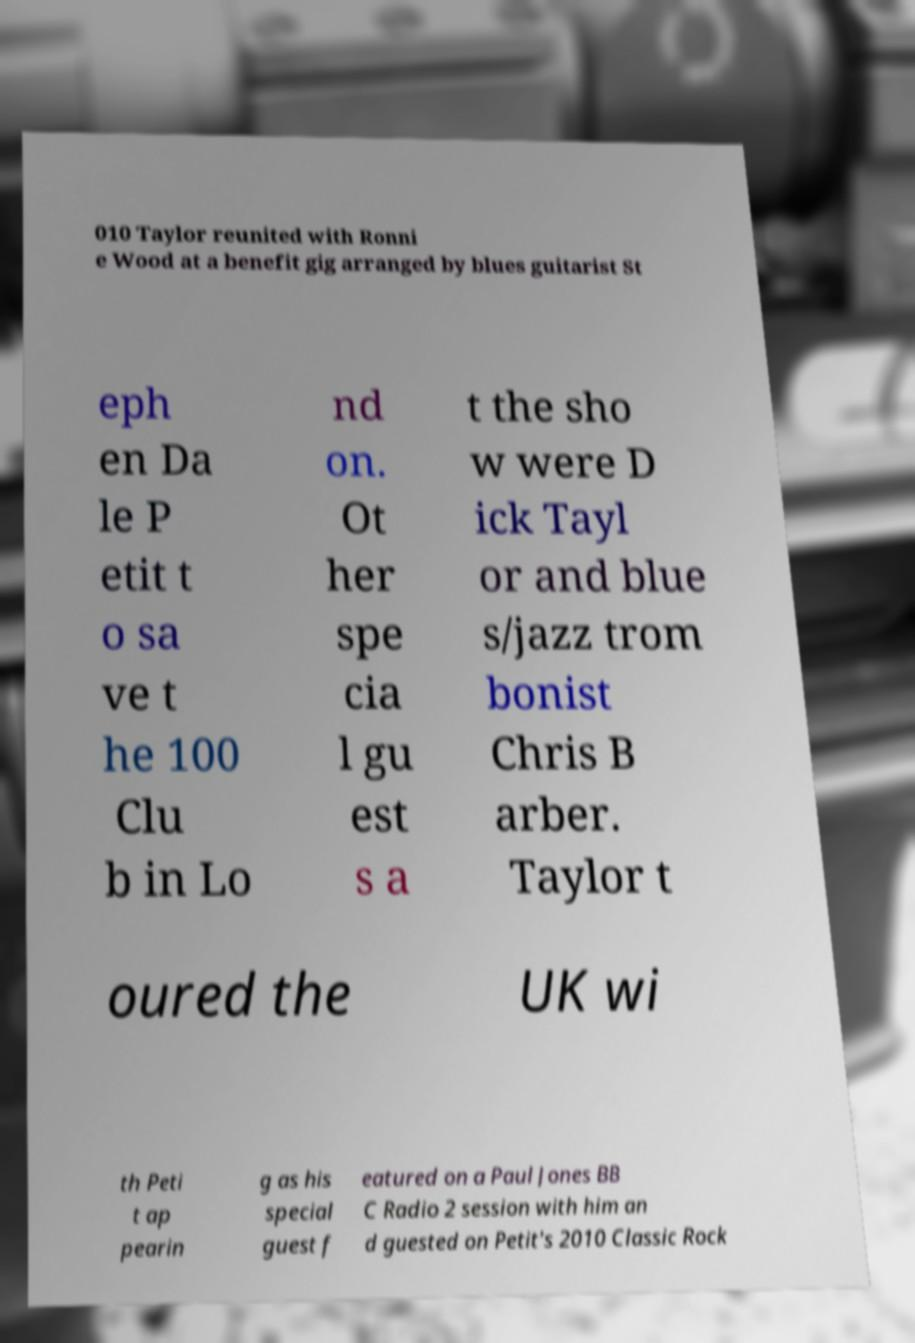Can you read and provide the text displayed in the image?This photo seems to have some interesting text. Can you extract and type it out for me? 010 Taylor reunited with Ronni e Wood at a benefit gig arranged by blues guitarist St eph en Da le P etit t o sa ve t he 100 Clu b in Lo nd on. Ot her spe cia l gu est s a t the sho w were D ick Tayl or and blue s/jazz trom bonist Chris B arber. Taylor t oured the UK wi th Peti t ap pearin g as his special guest f eatured on a Paul Jones BB C Radio 2 session with him an d guested on Petit's 2010 Classic Rock 